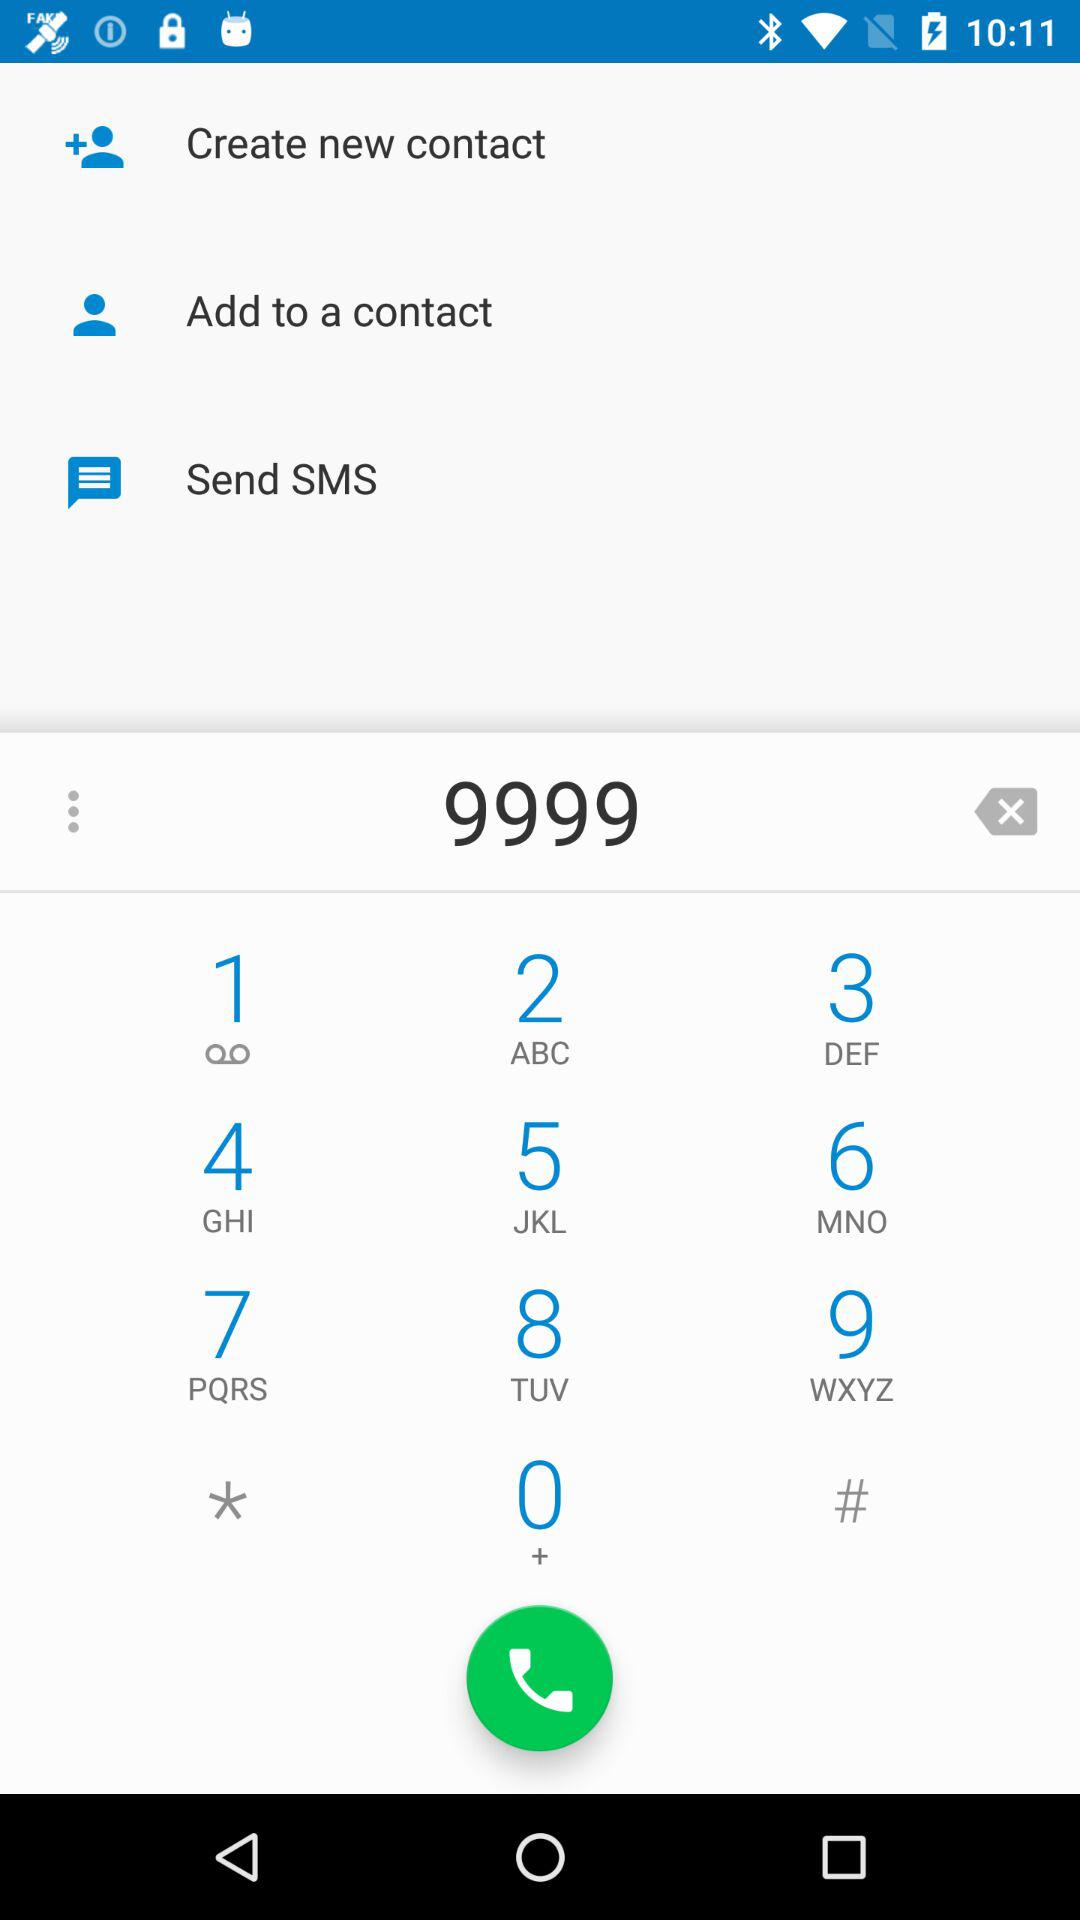What is the typed number? The typed number is 9999. 